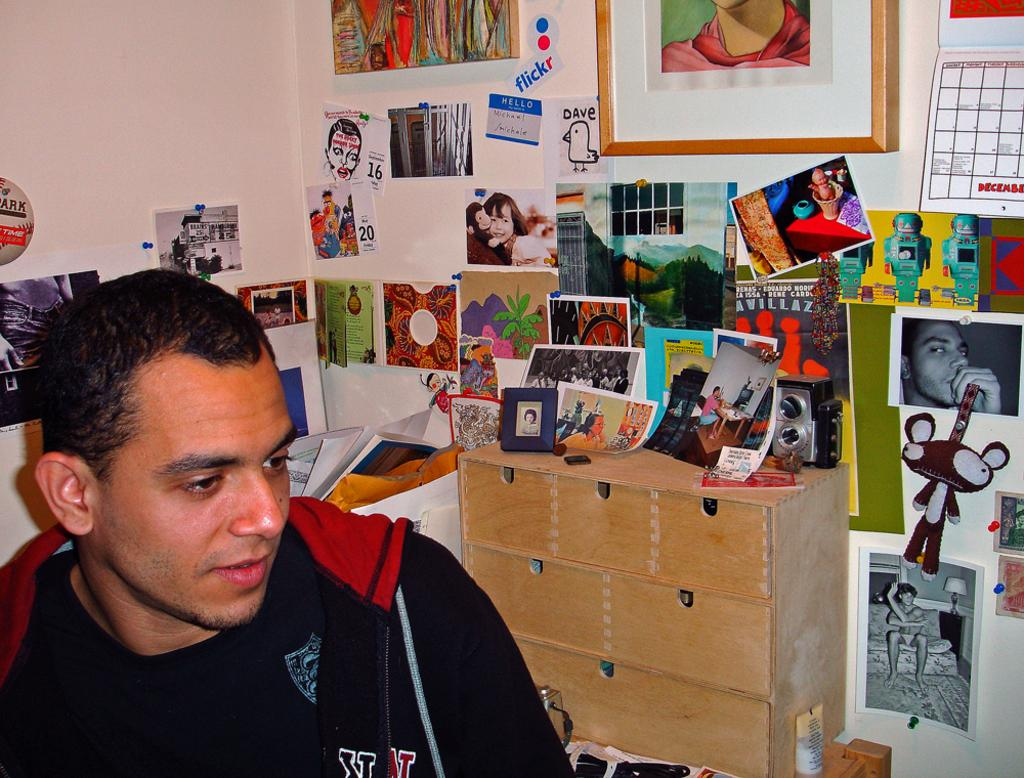What is the person in the image doing? The person is sitting on the left side of the image. What can be seen on the walls in the image? There are many papers attached to the walls in the image. Can you describe any other objects in the image? Yes, there is a photo frame and a cabinet in the image. How does the person in the image shake hands with the cap? There is no cap present in the image, and the person is sitting, not shaking hands. 